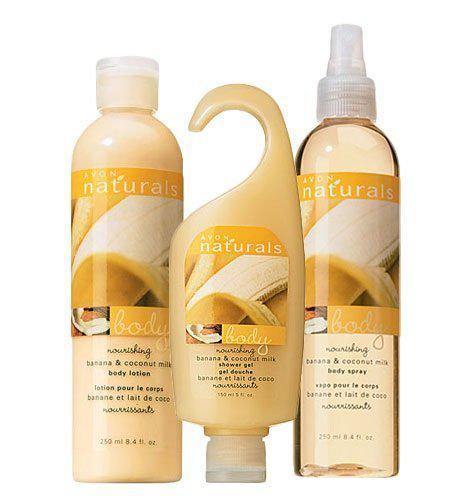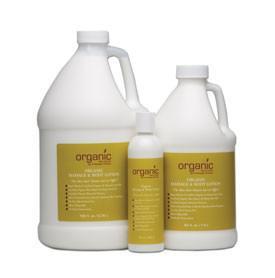The first image is the image on the left, the second image is the image on the right. Considering the images on both sides, is "All skincare items shown have pump dispensers, and at least one image contains only one skincare item." valid? Answer yes or no. No. The first image is the image on the left, the second image is the image on the right. Assess this claim about the two images: "The left and right image contains the same number of soaps and lotions.". Correct or not? Answer yes or no. Yes. 